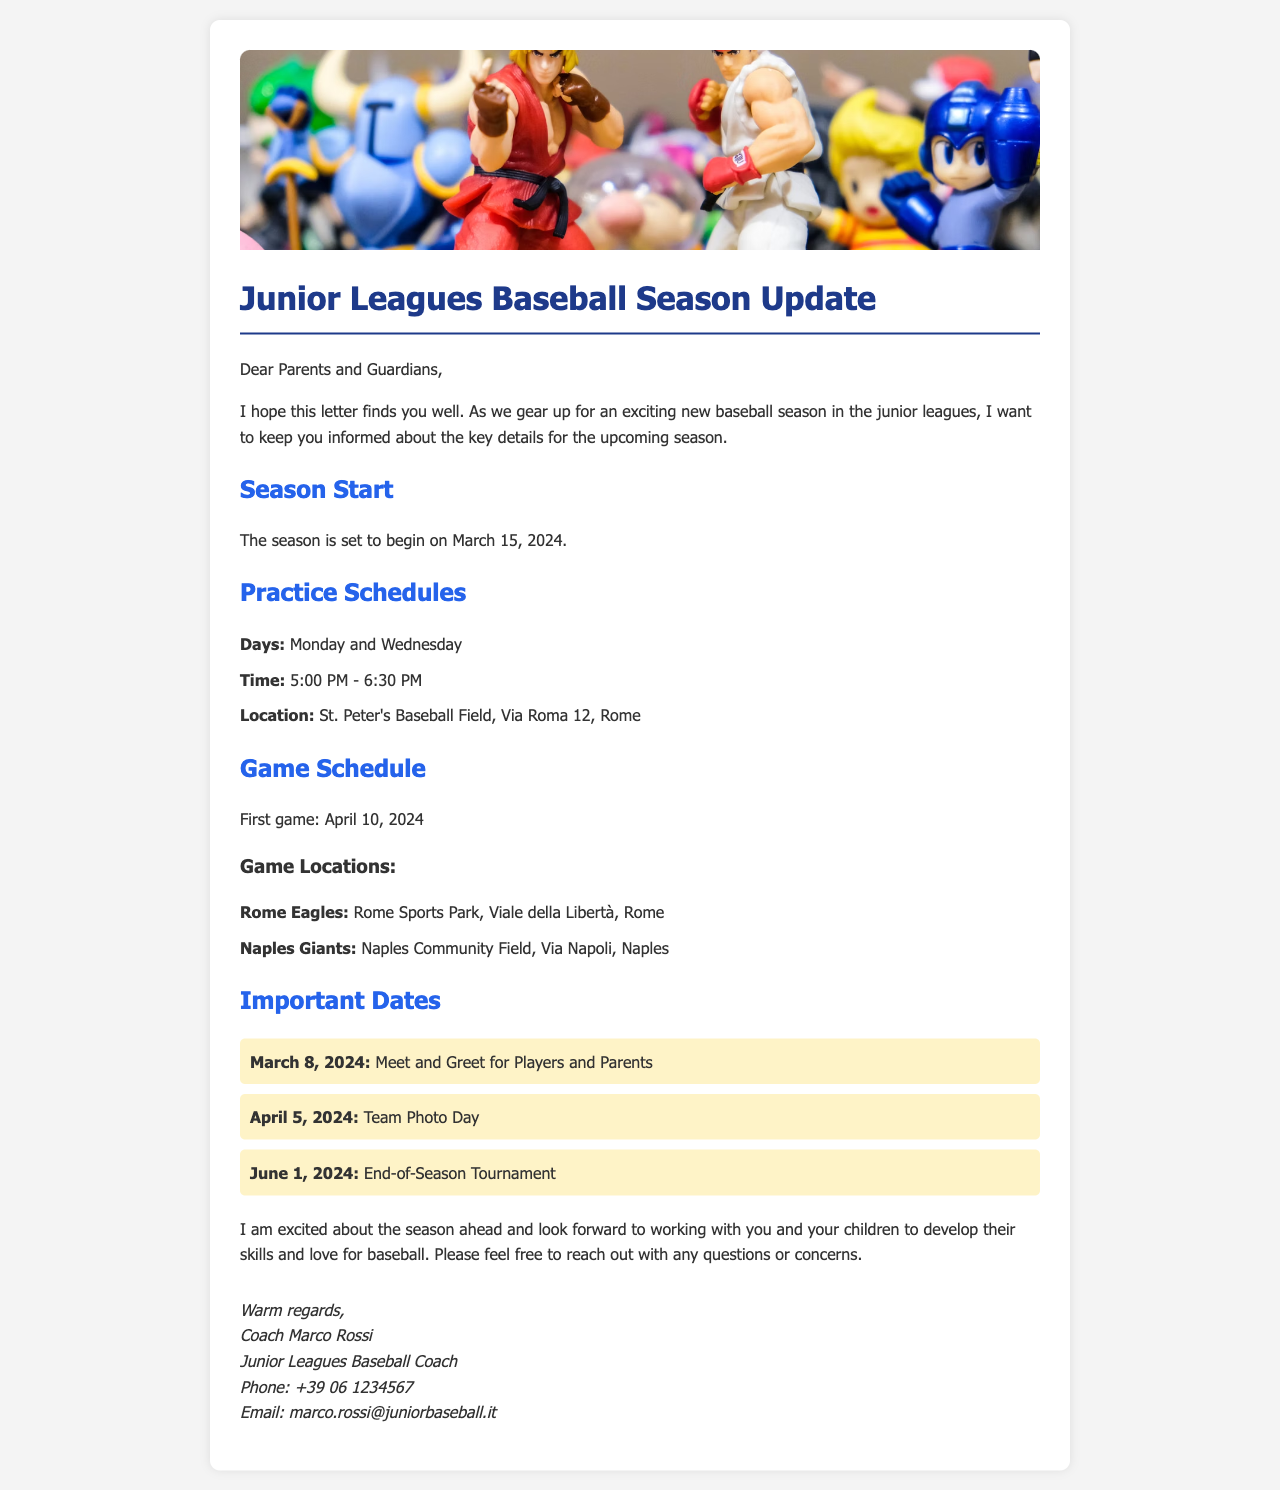What is the start date of the season? The start date of the season is stated in the document as March 15, 2024.
Answer: March 15, 2024 What are the practice days? The document specifies the days for practice as Monday and Wednesday.
Answer: Monday and Wednesday Where is the first game scheduled to be played? The document mentions that the first game will take place on April 10, 2024, but does not specify the location in this section. However, game locations are provided later in the document.
Answer: Rome Sports Park, Viale della Libertà, Rome What time do practices start? The document provides the start time for practices as 5:00 PM.
Answer: 5:00 PM What is the date for the Team Photo Day? The document lists the date for Team Photo Day as April 5, 2024.
Answer: April 5, 2024 How many important dates are listed in the document? The document lists three important dates related to the season.
Answer: Three What is the signature of the coach? The signature includes the name and title of the coach at the end of the letter.
Answer: Coach Marco Rossi What is the location for the practice sessions? The document specifies that practices are held at St. Peter's Baseball Field, Via Roma 12, Rome.
Answer: St. Peter's Baseball Field, Via Roma 12, Rome 